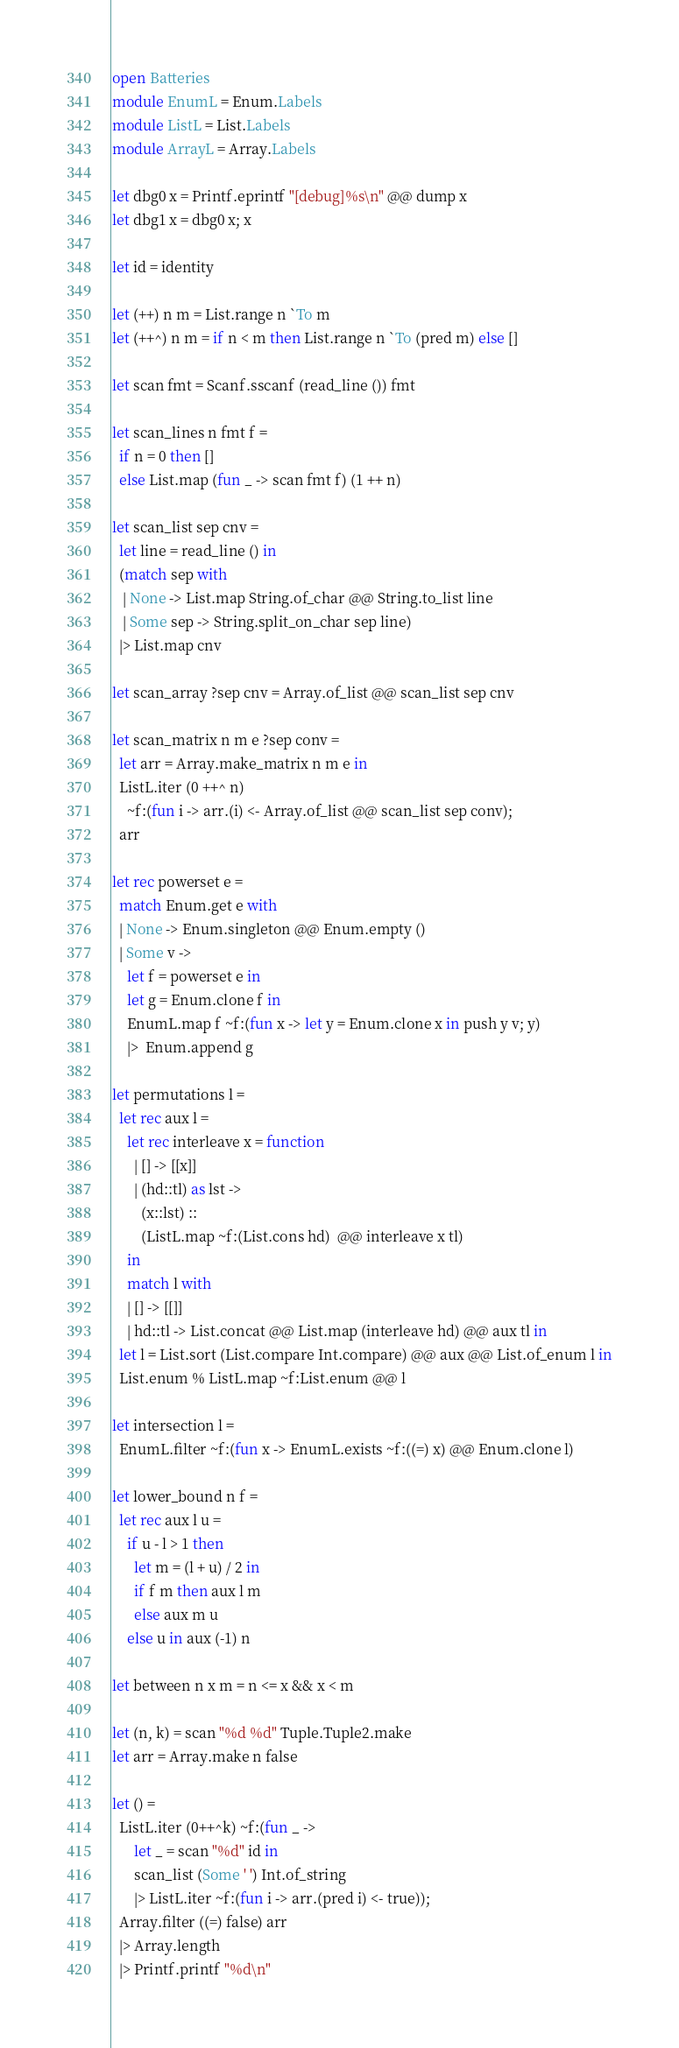<code> <loc_0><loc_0><loc_500><loc_500><_OCaml_>open Batteries
module EnumL = Enum.Labels
module ListL = List.Labels
module ArrayL = Array.Labels

let dbg0 x = Printf.eprintf "[debug]%s\n" @@ dump x
let dbg1 x = dbg0 x; x

let id = identity

let (++) n m = List.range n `To m
let (++^) n m = if n < m then List.range n `To (pred m) else []

let scan fmt = Scanf.sscanf (read_line ()) fmt

let scan_lines n fmt f =
  if n = 0 then []
  else List.map (fun _ -> scan fmt f) (1 ++ n)

let scan_list sep cnv =
  let line = read_line () in
  (match sep with
   | None -> List.map String.of_char @@ String.to_list line
   | Some sep -> String.split_on_char sep line)
  |> List.map cnv

let scan_array ?sep cnv = Array.of_list @@ scan_list sep cnv

let scan_matrix n m e ?sep conv =
  let arr = Array.make_matrix n m e in
  ListL.iter (0 ++^ n)
    ~f:(fun i -> arr.(i) <- Array.of_list @@ scan_list sep conv);
  arr

let rec powerset e =
  match Enum.get e with
  | None -> Enum.singleton @@ Enum.empty ()
  | Some v ->
    let f = powerset e in
    let g = Enum.clone f in
    EnumL.map f ~f:(fun x -> let y = Enum.clone x in push y v; y)
    |>  Enum.append g

let permutations l =
  let rec aux l =
    let rec interleave x = function
      | [] -> [[x]]
      | (hd::tl) as lst ->
        (x::lst) ::
        (ListL.map ~f:(List.cons hd)  @@ interleave x tl)
    in
    match l with
    | [] -> [[]]
    | hd::tl -> List.concat @@ List.map (interleave hd) @@ aux tl in
  let l = List.sort (List.compare Int.compare) @@ aux @@ List.of_enum l in
  List.enum % ListL.map ~f:List.enum @@ l

let intersection l =
  EnumL.filter ~f:(fun x -> EnumL.exists ~f:((=) x) @@ Enum.clone l)

let lower_bound n f =
  let rec aux l u =
    if u - l > 1 then
      let m = (l + u) / 2 in
      if f m then aux l m
      else aux m u
    else u in aux (-1) n

let between n x m = n <= x && x < m

let (n, k) = scan "%d %d" Tuple.Tuple2.make
let arr = Array.make n false

let () =
  ListL.iter (0++^k) ~f:(fun _ ->
      let _ = scan "%d" id in
      scan_list (Some ' ') Int.of_string
      |> ListL.iter ~f:(fun i -> arr.(pred i) <- true));
  Array.filter ((=) false) arr
  |> Array.length
  |> Printf.printf "%d\n"
</code> 